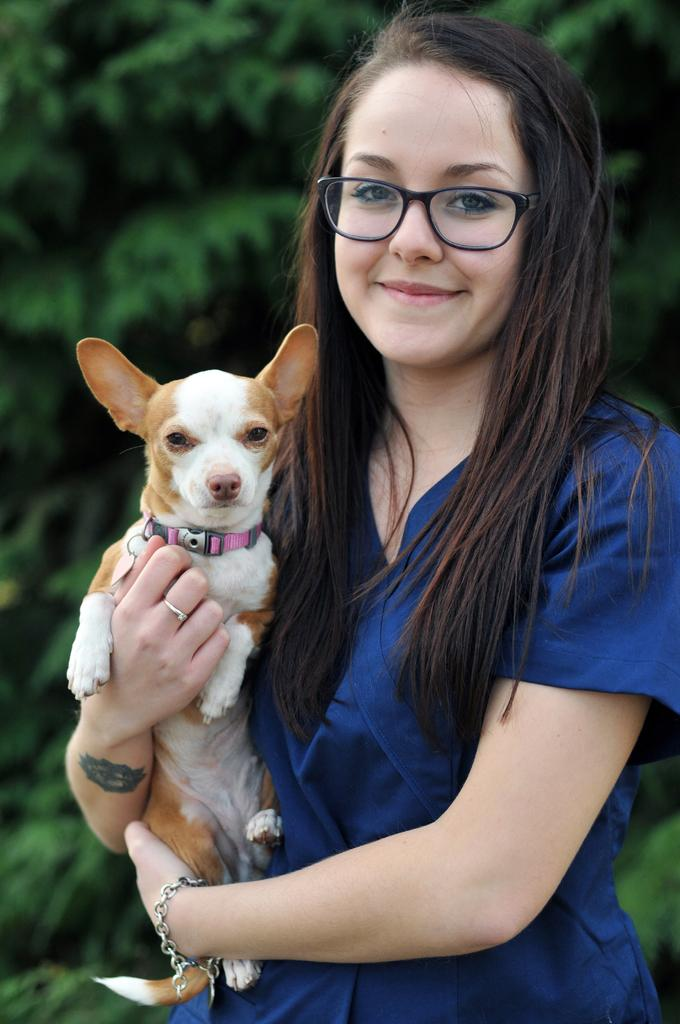Who is the main subject in the image? There is a lady in the image. What is the lady holding in the image? The lady is holding a dog. How is the lady holding the dog? The lady is using both of her hands to hold the dog. What type of nut can be seen in the lady's hand in the image? There is no nut present in the image; the lady is holding a dog with both of her hands. 